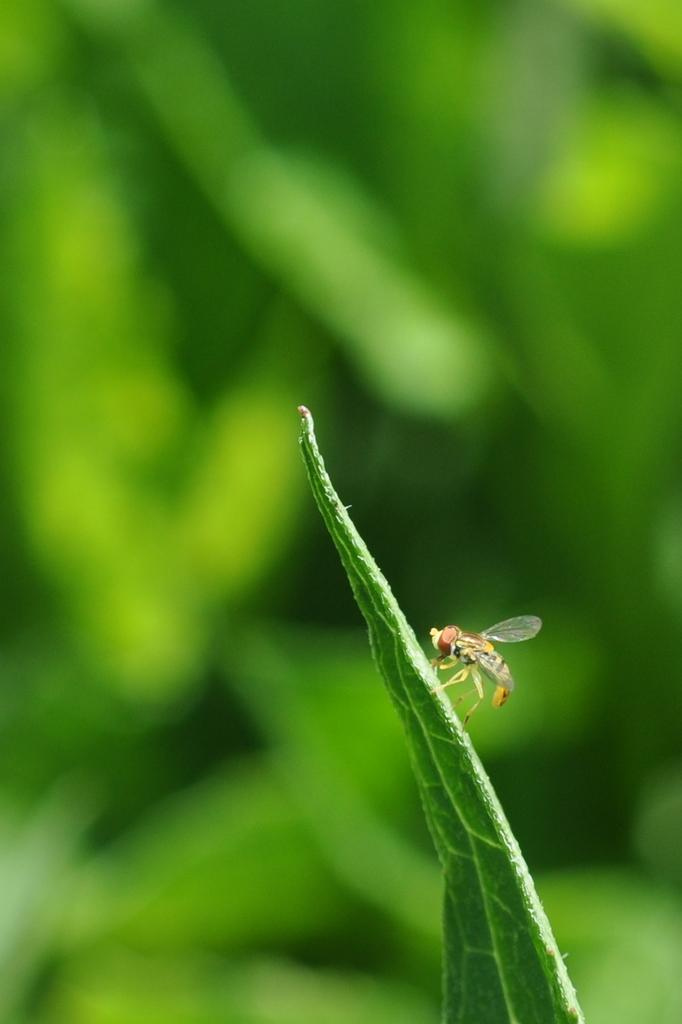What can be observed about the background of the image? The background of the image is blurry and green. What is present in the foreground of the image? There is an insect in the image. Where is the insect located? The insect is on a green leaf. What type of cover is the insect using to protect itself from the rain in the image? There is no indication of rain or a cover in the image; the insect is simply on a green leaf. 